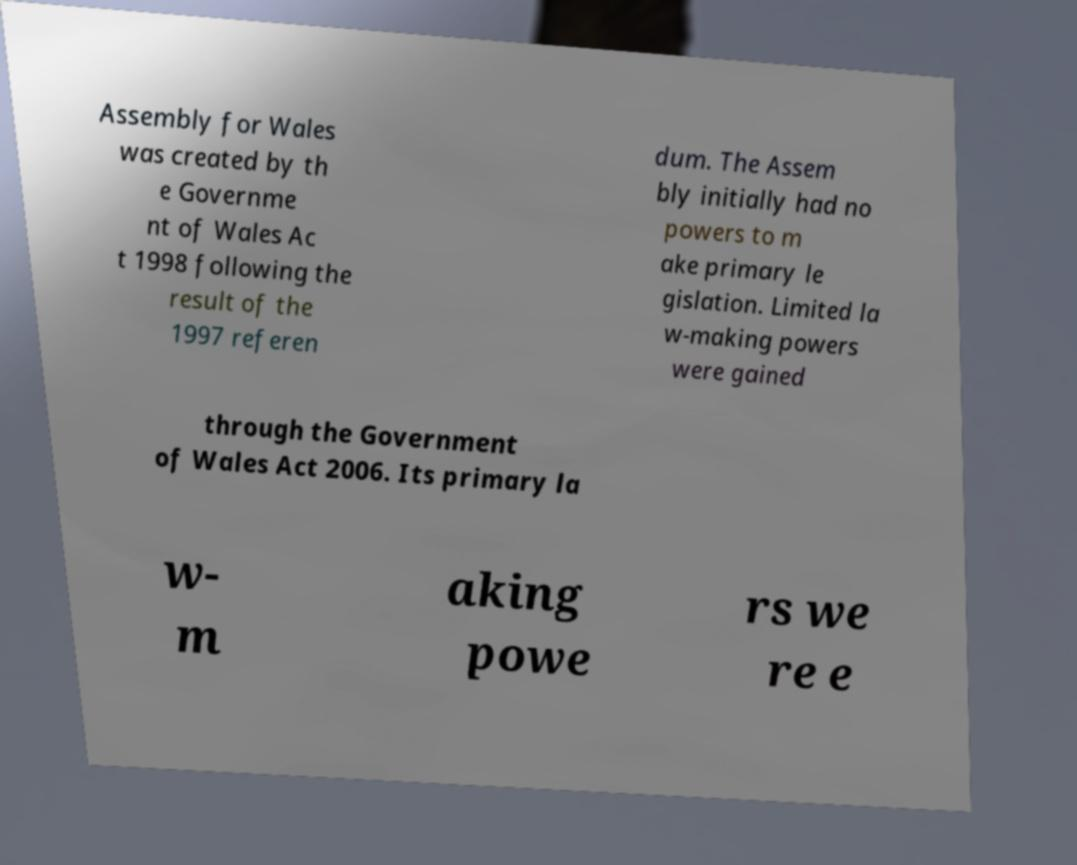Please read and relay the text visible in this image. What does it say? Assembly for Wales was created by th e Governme nt of Wales Ac t 1998 following the result of the 1997 referen dum. The Assem bly initially had no powers to m ake primary le gislation. Limited la w-making powers were gained through the Government of Wales Act 2006. Its primary la w- m aking powe rs we re e 